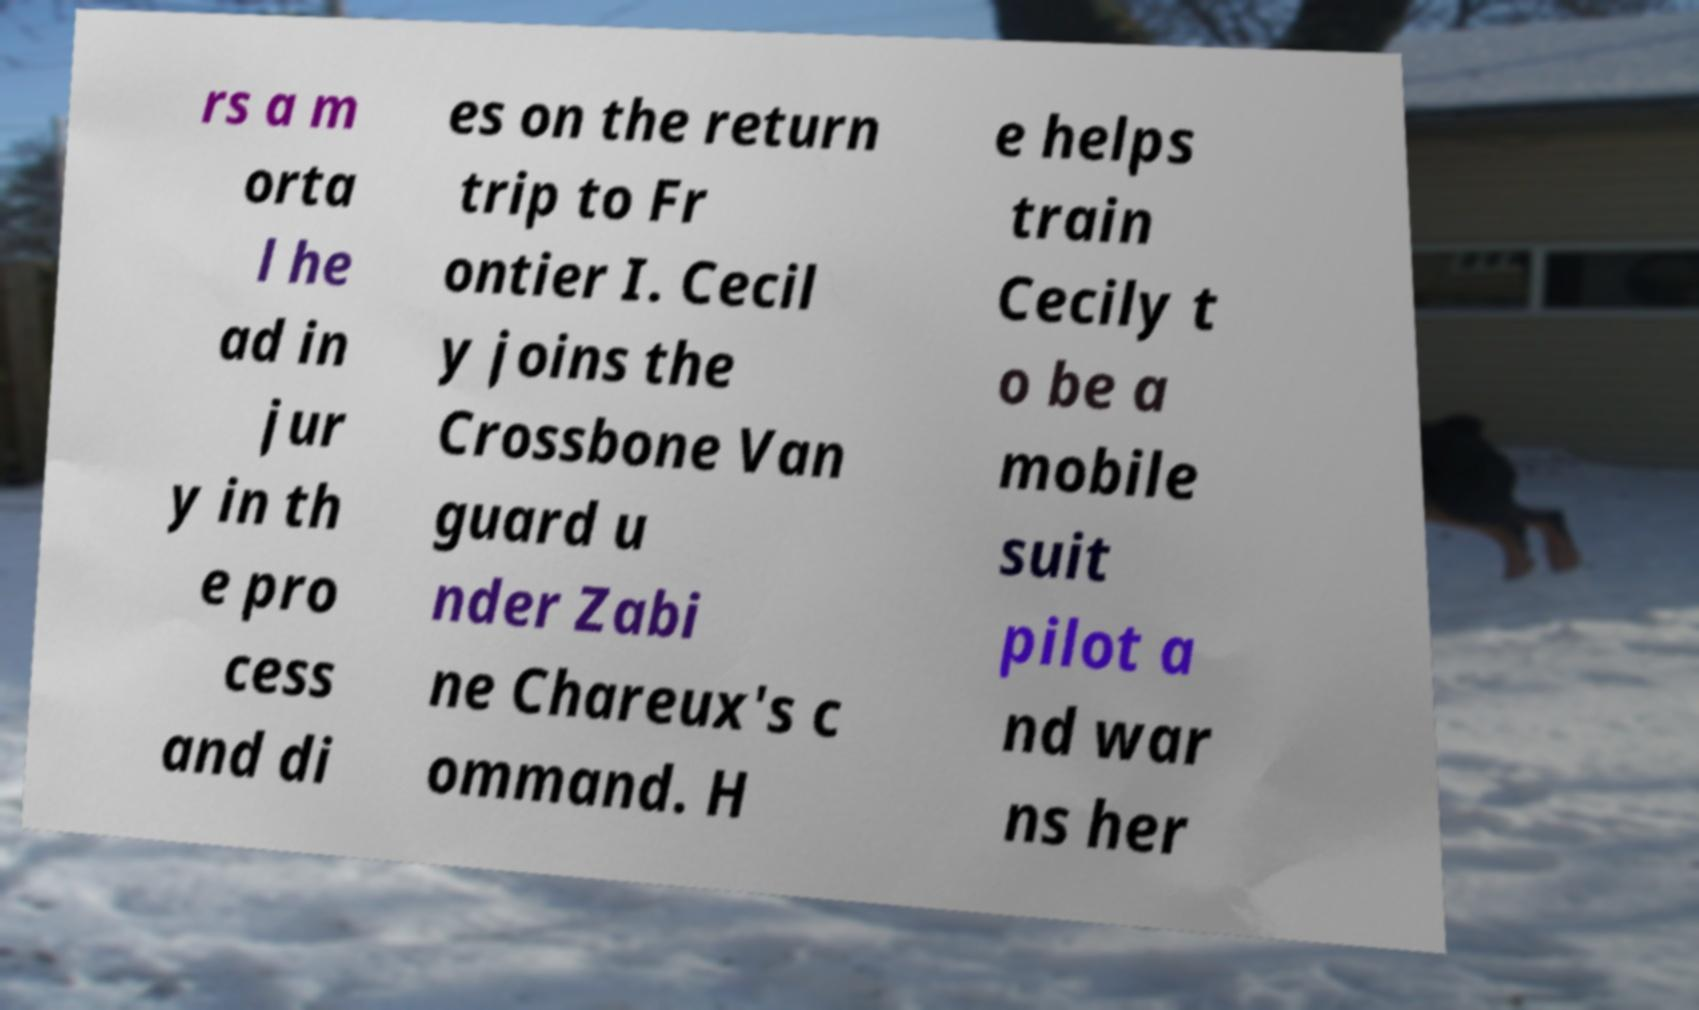Could you assist in decoding the text presented in this image and type it out clearly? rs a m orta l he ad in jur y in th e pro cess and di es on the return trip to Fr ontier I. Cecil y joins the Crossbone Van guard u nder Zabi ne Chareux's c ommand. H e helps train Cecily t o be a mobile suit pilot a nd war ns her 